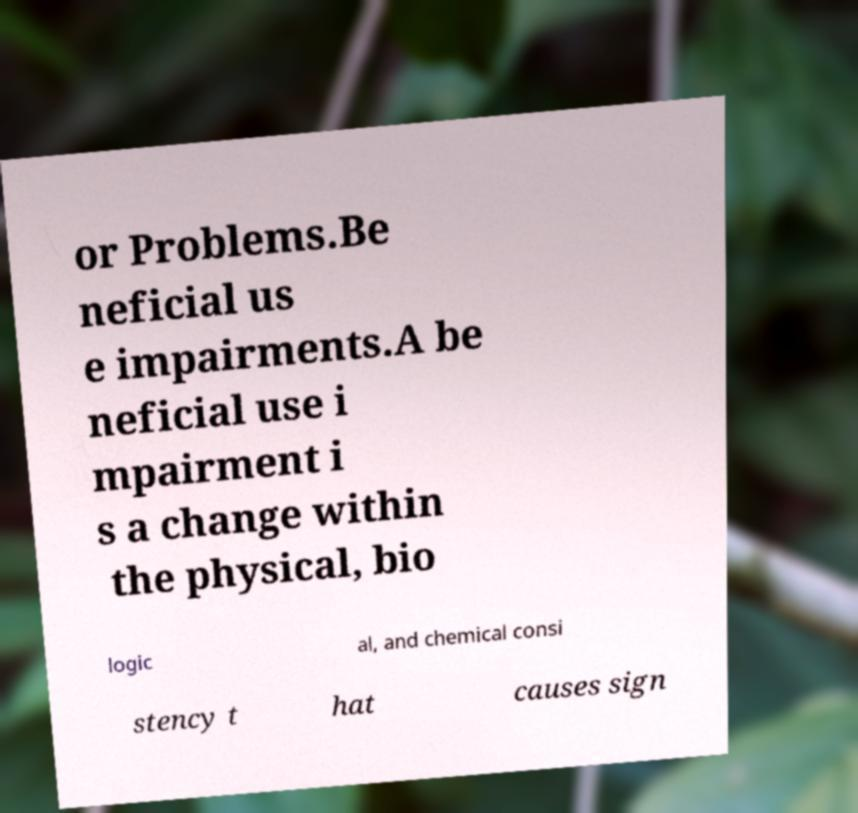Could you extract and type out the text from this image? or Problems.Be neficial us e impairments.A be neficial use i mpairment i s a change within the physical, bio logic al, and chemical consi stency t hat causes sign 